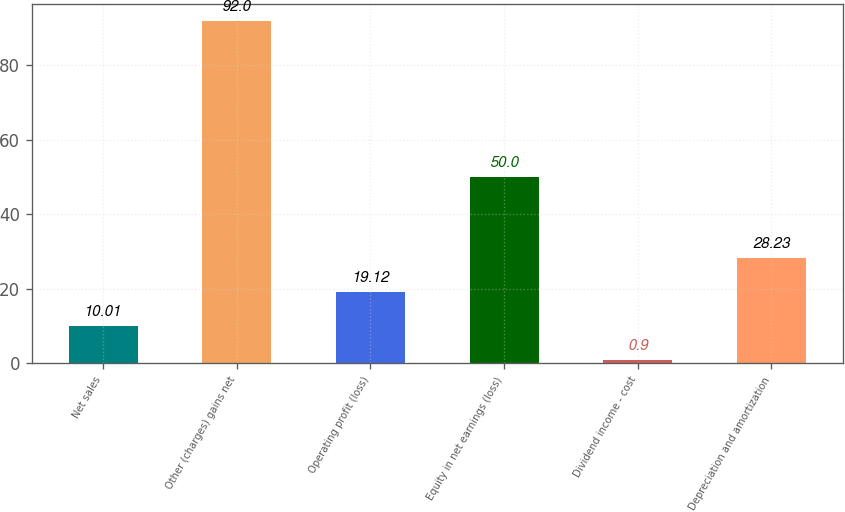<chart> <loc_0><loc_0><loc_500><loc_500><bar_chart><fcel>Net sales<fcel>Other (charges) gains net<fcel>Operating profit (loss)<fcel>Equity in net earnings (loss)<fcel>Dividend income - cost<fcel>Depreciation and amortization<nl><fcel>10.01<fcel>92<fcel>19.12<fcel>50<fcel>0.9<fcel>28.23<nl></chart> 